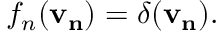Convert formula to latex. <formula><loc_0><loc_0><loc_500><loc_500>f _ { n } ( v _ { n } ) = \delta ( v _ { n } ) .</formula> 